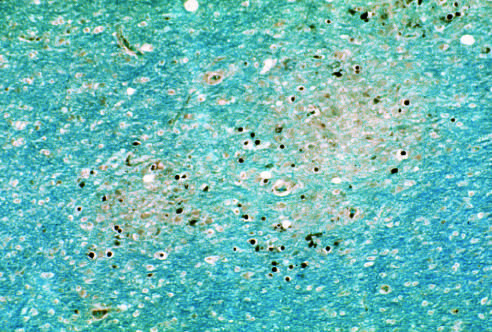what surround an area of early myelin loss?
Answer the question using a single word or phrase. Enlarged oligodendrocyte nuclei 